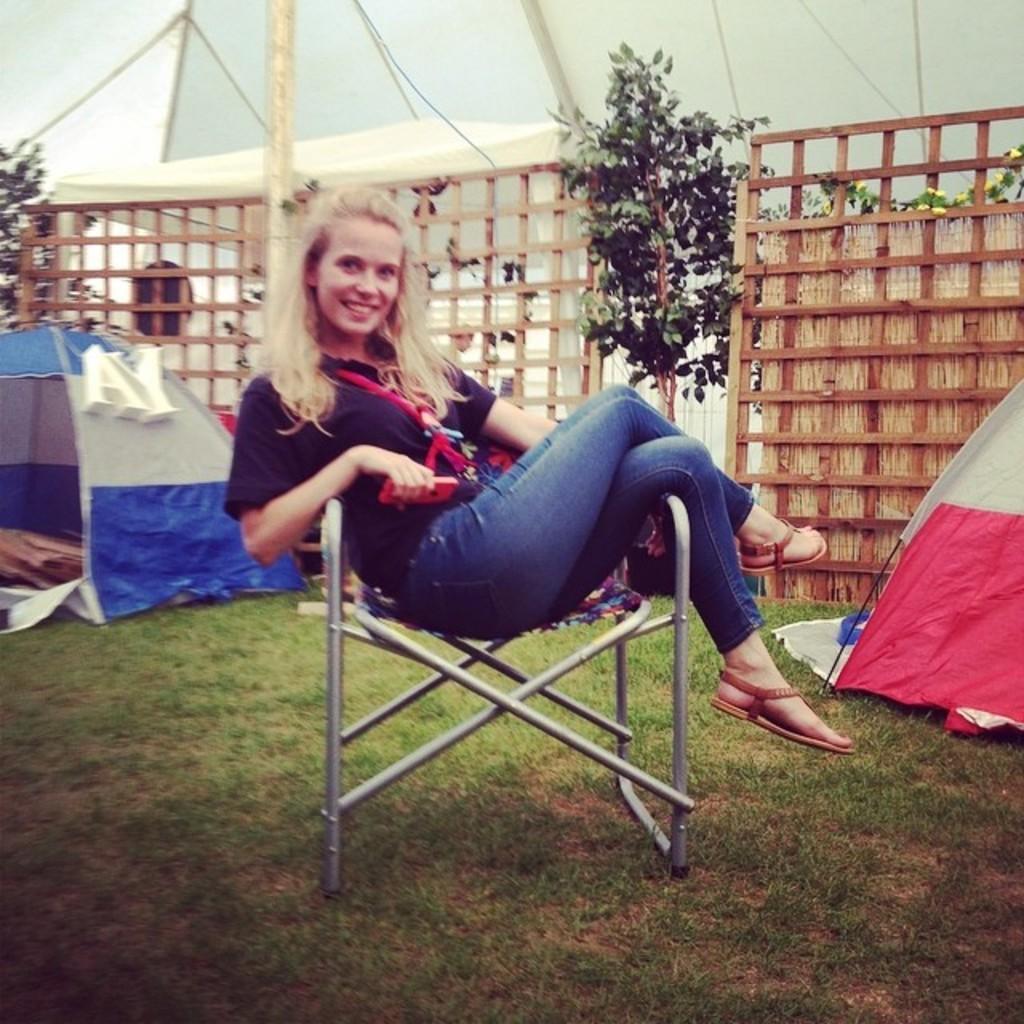Please provide a concise description of this image. This is a picture taken in the outdoors. The woman in black t shirt was sitting on a chair. Behind the women there are tents, plants and wooden fencing. 